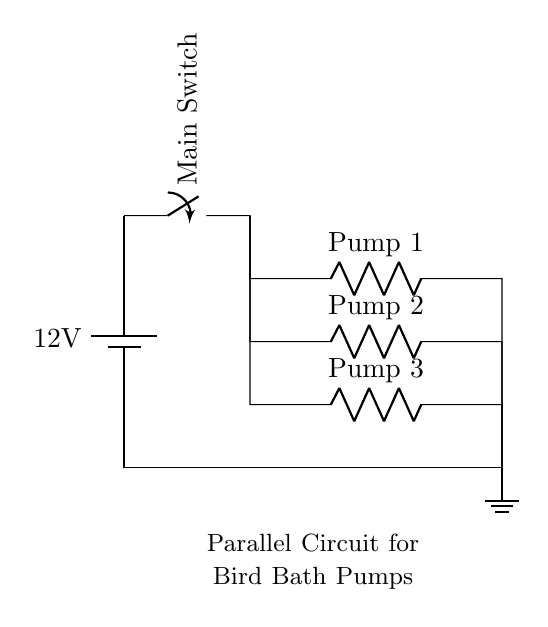What is the voltage of this circuit? The voltage is 12 volts, which is indicated next to the battery in the diagram.
Answer: 12 volts What types of components are used in this circuit? The components include a battery, a switch, and three pumps. The batteries provide voltage, the switch controls the flow, and the pumps are the devices working in the circuit.
Answer: Battery, switch, pumps How many pumps are connected in this parallel circuit? There are three pumps shown in the diagram, each connected in parallel to the same voltage source.
Answer: Three What is the main function of the switch in this circuit? The switch allows you to turn the entire circuit on or off. This means you can control whether power flows to all the pumps at once.
Answer: To control power flow If one pump fails, what happens in this circuit? If one pump fails, the other pumps remain operational because they are connected in parallel. Each pump operates independently in this configuration, so the failure of one doesn't affect the others.
Answer: Other pumps continue to work What is the role of the ground in this circuit? The ground serves as a common return path for the current. It completes the circuit, ensuring that current can flow from the battery through the pumps back to the battery.
Answer: Common return path What is the advantage of using a parallel circuit for these pumps? The advantage is that each pump receives the same voltage from the source, and if one pump fails, it doesn't affect the operation of others, allowing for consistent water flow to the bird bath.
Answer: Independent operation and consistent voltage 